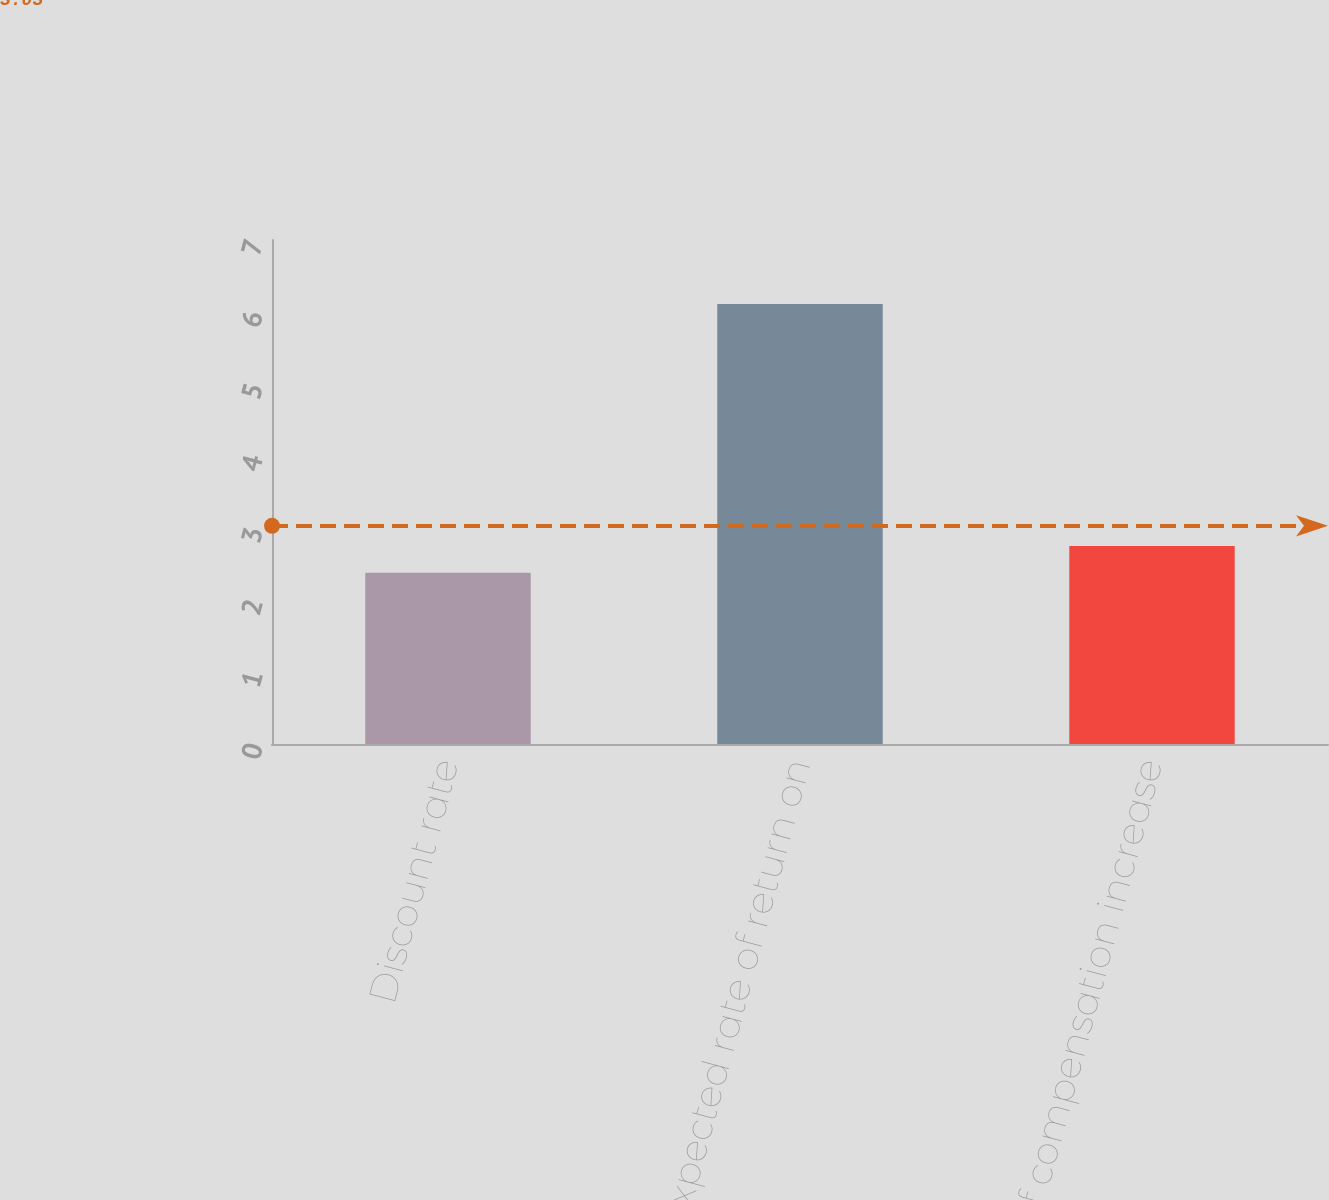<chart> <loc_0><loc_0><loc_500><loc_500><bar_chart><fcel>Discount rate<fcel>Expected rate of return on<fcel>Rate of compensation increase<nl><fcel>2.38<fcel>6.11<fcel>2.75<nl></chart> 